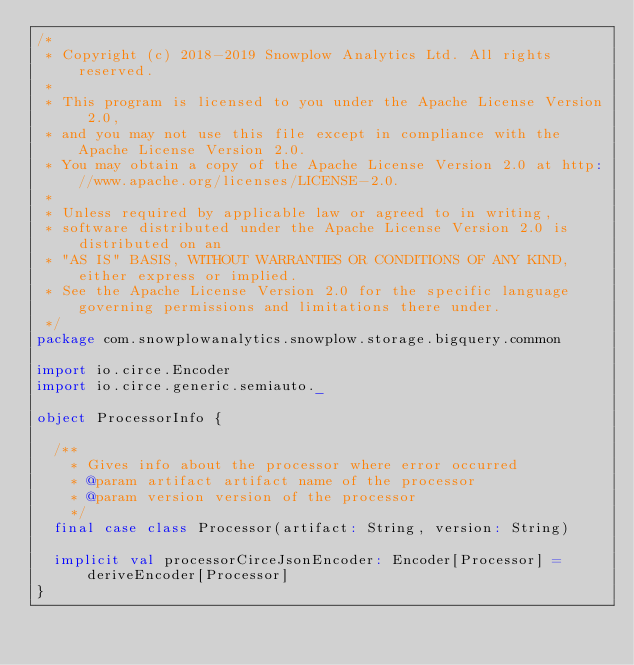<code> <loc_0><loc_0><loc_500><loc_500><_Scala_>/*
 * Copyright (c) 2018-2019 Snowplow Analytics Ltd. All rights reserved.
 *
 * This program is licensed to you under the Apache License Version 2.0,
 * and you may not use this file except in compliance with the Apache License Version 2.0.
 * You may obtain a copy of the Apache License Version 2.0 at http://www.apache.org/licenses/LICENSE-2.0.
 *
 * Unless required by applicable law or agreed to in writing,
 * software distributed under the Apache License Version 2.0 is distributed on an
 * "AS IS" BASIS, WITHOUT WARRANTIES OR CONDITIONS OF ANY KIND, either express or implied.
 * See the Apache License Version 2.0 for the specific language governing permissions and limitations there under.
 */
package com.snowplowanalytics.snowplow.storage.bigquery.common

import io.circe.Encoder
import io.circe.generic.semiauto._

object ProcessorInfo {

  /**
    * Gives info about the processor where error occurred
    * @param artifact artifact name of the processor
    * @param version version of the processor
    */
  final case class Processor(artifact: String, version: String)

  implicit val processorCirceJsonEncoder: Encoder[Processor] = deriveEncoder[Processor]
}
</code> 